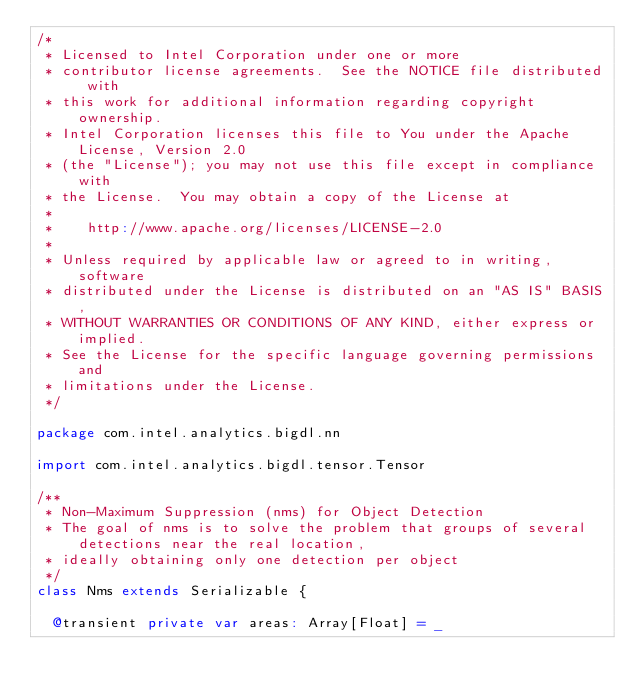<code> <loc_0><loc_0><loc_500><loc_500><_Scala_>/*
 * Licensed to Intel Corporation under one or more
 * contributor license agreements.  See the NOTICE file distributed with
 * this work for additional information regarding copyright ownership.
 * Intel Corporation licenses this file to You under the Apache License, Version 2.0
 * (the "License"); you may not use this file except in compliance with
 * the License.  You may obtain a copy of the License at
 *
 *    http://www.apache.org/licenses/LICENSE-2.0
 *
 * Unless required by applicable law or agreed to in writing, software
 * distributed under the License is distributed on an "AS IS" BASIS,
 * WITHOUT WARRANTIES OR CONDITIONS OF ANY KIND, either express or implied.
 * See the License for the specific language governing permissions and
 * limitations under the License.
 */

package com.intel.analytics.bigdl.nn

import com.intel.analytics.bigdl.tensor.Tensor

/**
 * Non-Maximum Suppression (nms) for Object Detection
 * The goal of nms is to solve the problem that groups of several detections near the real location,
 * ideally obtaining only one detection per object
 */
class Nms extends Serializable {

  @transient private var areas: Array[Float] = _</code> 